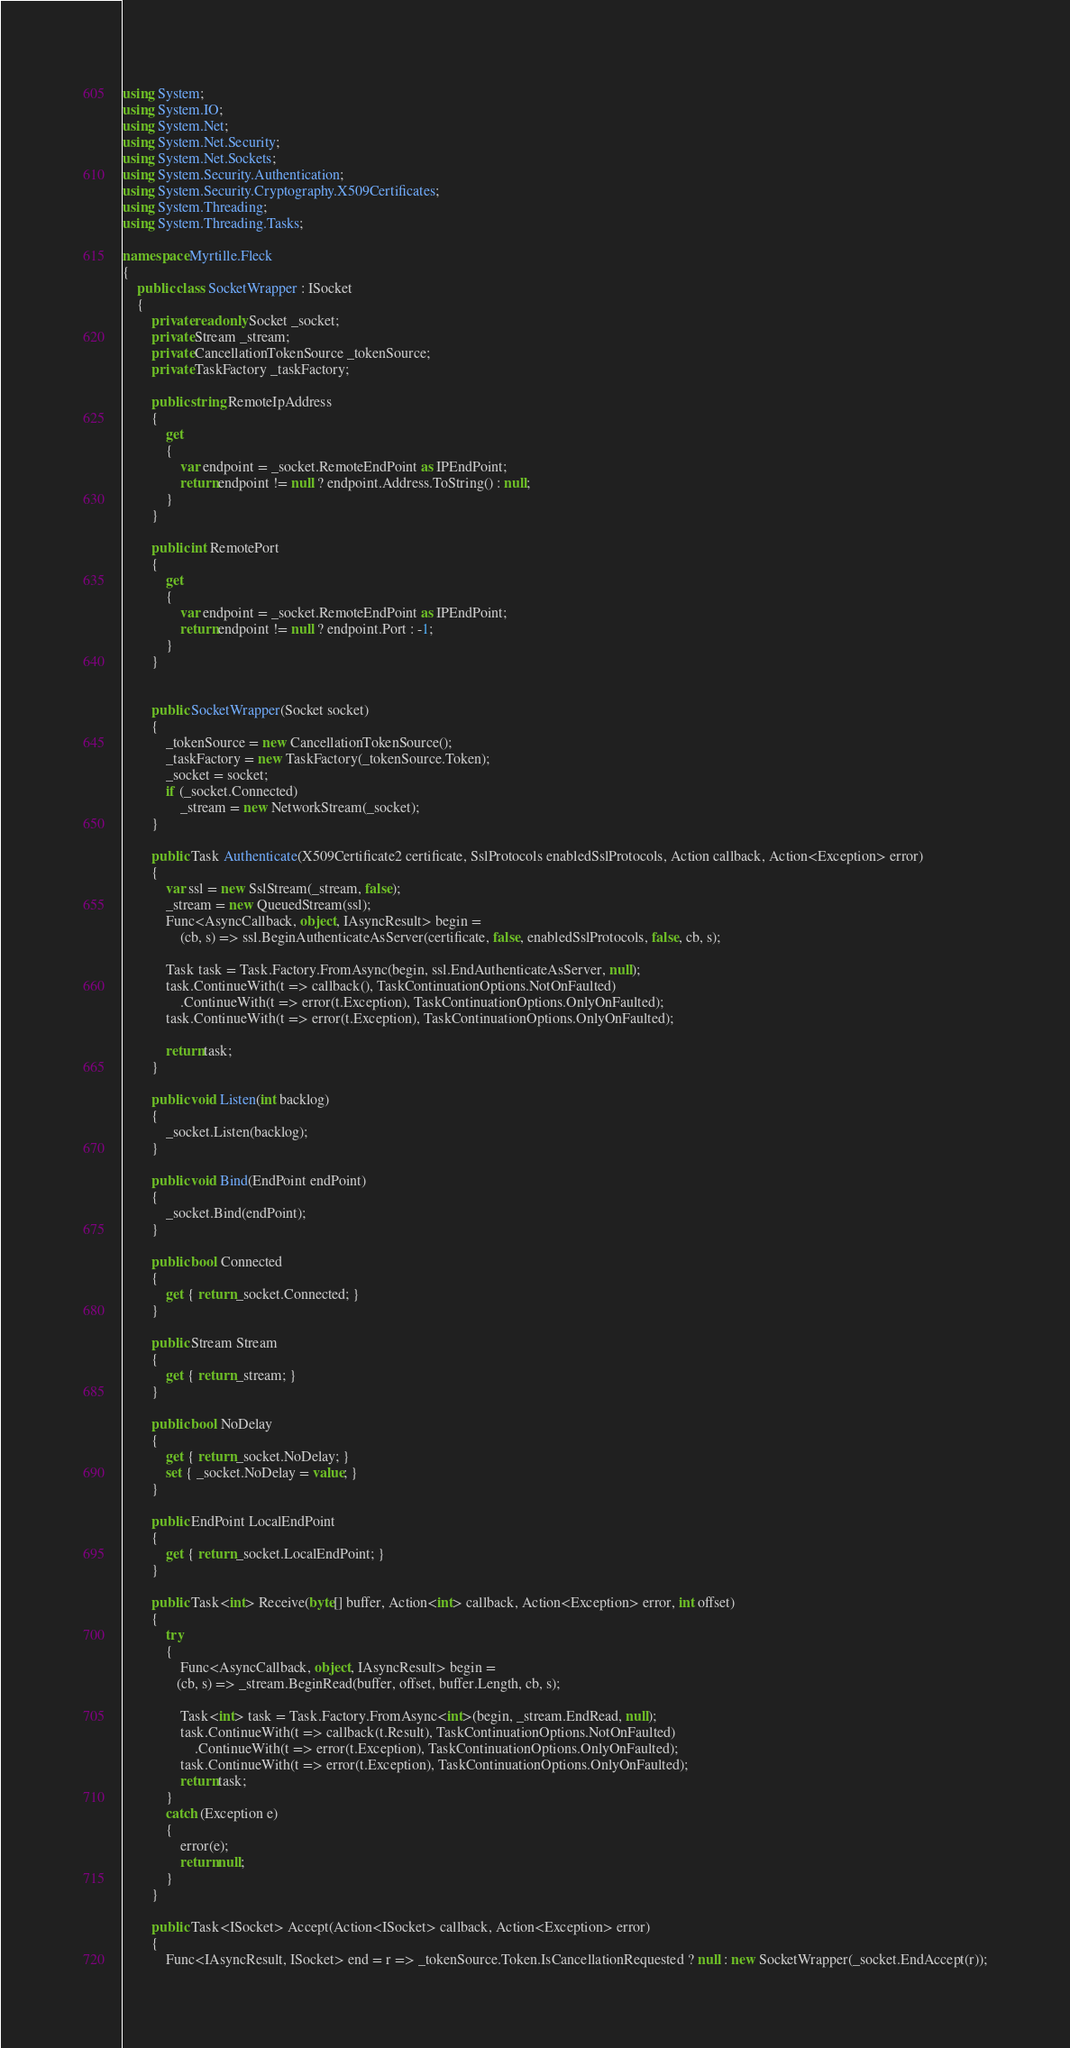<code> <loc_0><loc_0><loc_500><loc_500><_C#_>using System;
using System.IO;
using System.Net;
using System.Net.Security;
using System.Net.Sockets;
using System.Security.Authentication;
using System.Security.Cryptography.X509Certificates;
using System.Threading;
using System.Threading.Tasks;

namespace Myrtille.Fleck
{
    public class SocketWrapper : ISocket
    {
        private readonly Socket _socket;
        private Stream _stream;
        private CancellationTokenSource _tokenSource;
        private TaskFactory _taskFactory;
        
        public string RemoteIpAddress
        {
            get
            {
                var endpoint = _socket.RemoteEndPoint as IPEndPoint;
                return endpoint != null ? endpoint.Address.ToString() : null;
            }
        }

        public int RemotePort
        {
            get
            {
                var endpoint = _socket.RemoteEndPoint as IPEndPoint;
                return endpoint != null ? endpoint.Port : -1;
            }
        }


        public SocketWrapper(Socket socket)
        {
            _tokenSource = new CancellationTokenSource();
            _taskFactory = new TaskFactory(_tokenSource.Token);
            _socket = socket;
            if (_socket.Connected)
                _stream = new NetworkStream(_socket);
        }

        public Task Authenticate(X509Certificate2 certificate, SslProtocols enabledSslProtocols, Action callback, Action<Exception> error)
        {
            var ssl = new SslStream(_stream, false);
            _stream = new QueuedStream(ssl);
            Func<AsyncCallback, object, IAsyncResult> begin =
                (cb, s) => ssl.BeginAuthenticateAsServer(certificate, false, enabledSslProtocols, false, cb, s);
                
            Task task = Task.Factory.FromAsync(begin, ssl.EndAuthenticateAsServer, null);
            task.ContinueWith(t => callback(), TaskContinuationOptions.NotOnFaulted)
                .ContinueWith(t => error(t.Exception), TaskContinuationOptions.OnlyOnFaulted);
            task.ContinueWith(t => error(t.Exception), TaskContinuationOptions.OnlyOnFaulted);

            return task;
        }

        public void Listen(int backlog)
        {
            _socket.Listen(backlog);
        }

        public void Bind(EndPoint endPoint)
        {
            _socket.Bind(endPoint);
        }

        public bool Connected
        {
            get { return _socket.Connected; }
        }
        
        public Stream Stream
        {
            get { return _stream; }
        }

        public bool NoDelay
        {
            get { return _socket.NoDelay; }
            set { _socket.NoDelay = value; }
        }

        public EndPoint LocalEndPoint
        {
            get { return _socket.LocalEndPoint; }
        }

        public Task<int> Receive(byte[] buffer, Action<int> callback, Action<Exception> error, int offset)
        {
            try
            {
                Func<AsyncCallback, object, IAsyncResult> begin =
               (cb, s) => _stream.BeginRead(buffer, offset, buffer.Length, cb, s);

                Task<int> task = Task.Factory.FromAsync<int>(begin, _stream.EndRead, null);
                task.ContinueWith(t => callback(t.Result), TaskContinuationOptions.NotOnFaulted)
                    .ContinueWith(t => error(t.Exception), TaskContinuationOptions.OnlyOnFaulted);
                task.ContinueWith(t => error(t.Exception), TaskContinuationOptions.OnlyOnFaulted);
                return task;
            }
            catch (Exception e)
            {
                error(e);
                return null;
            }
        }

        public Task<ISocket> Accept(Action<ISocket> callback, Action<Exception> error)
        {
            Func<IAsyncResult, ISocket> end = r => _tokenSource.Token.IsCancellationRequested ? null : new SocketWrapper(_socket.EndAccept(r));</code> 